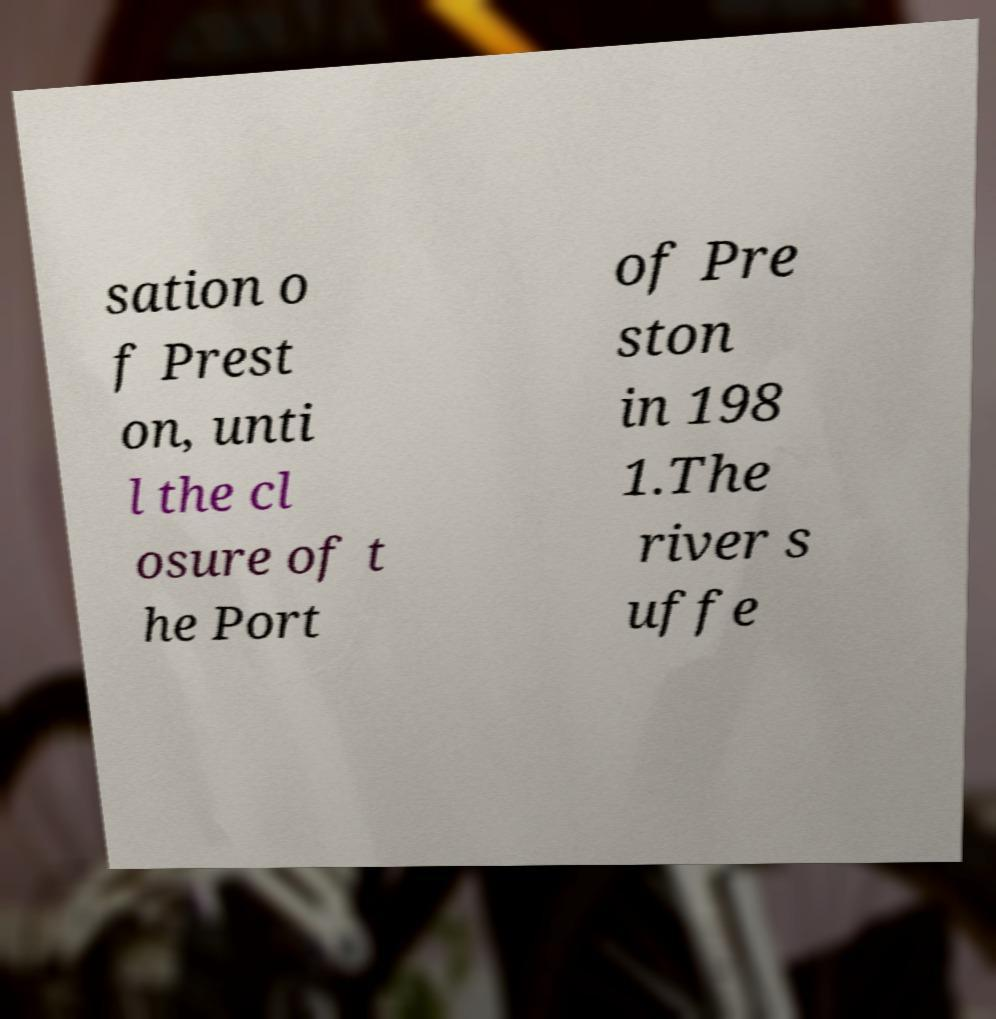Please read and relay the text visible in this image. What does it say? sation o f Prest on, unti l the cl osure of t he Port of Pre ston in 198 1.The river s uffe 